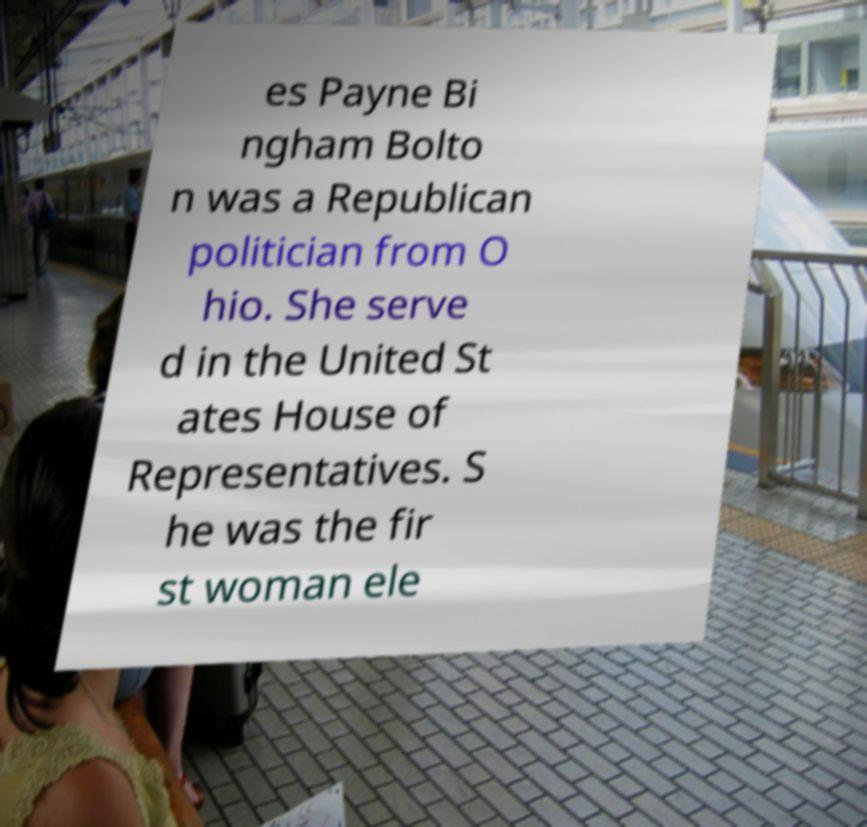Could you extract and type out the text from this image? es Payne Bi ngham Bolto n was a Republican politician from O hio. She serve d in the United St ates House of Representatives. S he was the fir st woman ele 